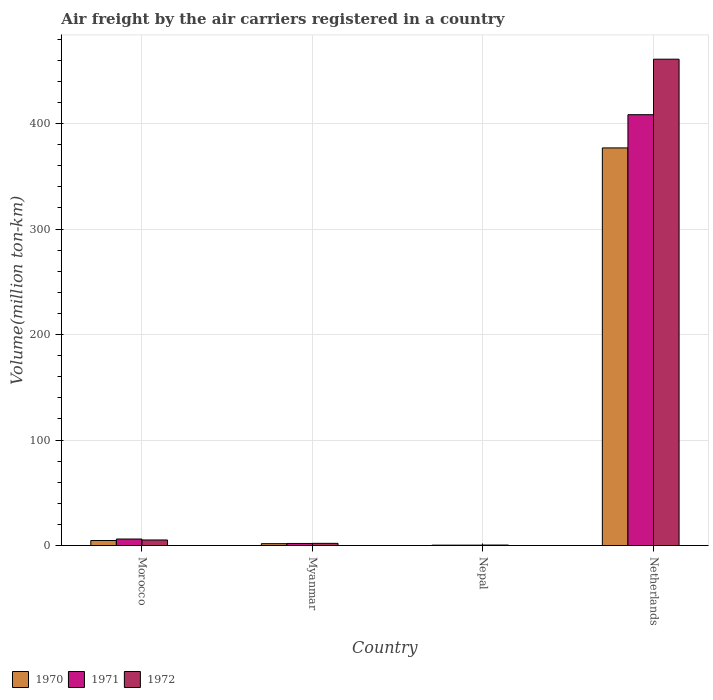How many different coloured bars are there?
Make the answer very short. 3. How many groups of bars are there?
Give a very brief answer. 4. What is the label of the 1st group of bars from the left?
Keep it short and to the point. Morocco. What is the volume of the air carriers in 1971 in Netherlands?
Provide a succinct answer. 408.4. Across all countries, what is the maximum volume of the air carriers in 1970?
Keep it short and to the point. 376.9. Across all countries, what is the minimum volume of the air carriers in 1970?
Offer a very short reply. 0.4. In which country was the volume of the air carriers in 1972 minimum?
Keep it short and to the point. Nepal. What is the total volume of the air carriers in 1970 in the graph?
Provide a succinct answer. 383.9. What is the difference between the volume of the air carriers in 1970 in Morocco and that in Myanmar?
Give a very brief answer. 3. What is the difference between the volume of the air carriers in 1970 in Myanmar and the volume of the air carriers in 1971 in Nepal?
Make the answer very short. 1.4. What is the average volume of the air carriers in 1971 per country?
Your answer should be very brief. 104.25. What is the difference between the volume of the air carriers of/in 1972 and volume of the air carriers of/in 1970 in Netherlands?
Give a very brief answer. 84.1. What is the ratio of the volume of the air carriers in 1972 in Myanmar to that in Nepal?
Keep it short and to the point. 4.2. What is the difference between the highest and the second highest volume of the air carriers in 1971?
Give a very brief answer. 406.4. What is the difference between the highest and the lowest volume of the air carriers in 1971?
Provide a succinct answer. 408. In how many countries, is the volume of the air carriers in 1970 greater than the average volume of the air carriers in 1970 taken over all countries?
Keep it short and to the point. 1. What does the 2nd bar from the left in Nepal represents?
Give a very brief answer. 1971. What does the 1st bar from the right in Morocco represents?
Ensure brevity in your answer.  1972. Is it the case that in every country, the sum of the volume of the air carriers in 1971 and volume of the air carriers in 1972 is greater than the volume of the air carriers in 1970?
Your answer should be very brief. Yes. Are all the bars in the graph horizontal?
Ensure brevity in your answer.  No. What is the difference between two consecutive major ticks on the Y-axis?
Provide a succinct answer. 100. Are the values on the major ticks of Y-axis written in scientific E-notation?
Your answer should be compact. No. How are the legend labels stacked?
Give a very brief answer. Horizontal. What is the title of the graph?
Ensure brevity in your answer.  Air freight by the air carriers registered in a country. Does "1960" appear as one of the legend labels in the graph?
Your answer should be very brief. No. What is the label or title of the X-axis?
Make the answer very short. Country. What is the label or title of the Y-axis?
Provide a succinct answer. Volume(million ton-km). What is the Volume(million ton-km) in 1970 in Morocco?
Your answer should be very brief. 4.8. What is the Volume(million ton-km) of 1971 in Morocco?
Your response must be concise. 6.2. What is the Volume(million ton-km) of 1972 in Morocco?
Give a very brief answer. 5.3. What is the Volume(million ton-km) in 1970 in Myanmar?
Your answer should be compact. 1.8. What is the Volume(million ton-km) of 1972 in Myanmar?
Your answer should be compact. 2.1. What is the Volume(million ton-km) of 1970 in Nepal?
Make the answer very short. 0.4. What is the Volume(million ton-km) in 1971 in Nepal?
Offer a very short reply. 0.4. What is the Volume(million ton-km) in 1970 in Netherlands?
Your answer should be compact. 376.9. What is the Volume(million ton-km) in 1971 in Netherlands?
Offer a very short reply. 408.4. What is the Volume(million ton-km) in 1972 in Netherlands?
Ensure brevity in your answer.  461. Across all countries, what is the maximum Volume(million ton-km) of 1970?
Keep it short and to the point. 376.9. Across all countries, what is the maximum Volume(million ton-km) in 1971?
Make the answer very short. 408.4. Across all countries, what is the maximum Volume(million ton-km) of 1972?
Make the answer very short. 461. Across all countries, what is the minimum Volume(million ton-km) of 1970?
Give a very brief answer. 0.4. Across all countries, what is the minimum Volume(million ton-km) in 1971?
Offer a very short reply. 0.4. What is the total Volume(million ton-km) of 1970 in the graph?
Your response must be concise. 383.9. What is the total Volume(million ton-km) in 1971 in the graph?
Provide a short and direct response. 417. What is the total Volume(million ton-km) of 1972 in the graph?
Ensure brevity in your answer.  468.9. What is the difference between the Volume(million ton-km) of 1970 in Morocco and that in Myanmar?
Make the answer very short. 3. What is the difference between the Volume(million ton-km) in 1970 in Morocco and that in Nepal?
Provide a short and direct response. 4.4. What is the difference between the Volume(million ton-km) in 1971 in Morocco and that in Nepal?
Your answer should be very brief. 5.8. What is the difference between the Volume(million ton-km) of 1970 in Morocco and that in Netherlands?
Give a very brief answer. -372.1. What is the difference between the Volume(million ton-km) in 1971 in Morocco and that in Netherlands?
Your answer should be compact. -402.2. What is the difference between the Volume(million ton-km) of 1972 in Morocco and that in Netherlands?
Your response must be concise. -455.7. What is the difference between the Volume(million ton-km) of 1970 in Myanmar and that in Netherlands?
Provide a succinct answer. -375.1. What is the difference between the Volume(million ton-km) of 1971 in Myanmar and that in Netherlands?
Offer a terse response. -406.4. What is the difference between the Volume(million ton-km) in 1972 in Myanmar and that in Netherlands?
Your response must be concise. -458.9. What is the difference between the Volume(million ton-km) in 1970 in Nepal and that in Netherlands?
Your response must be concise. -376.5. What is the difference between the Volume(million ton-km) of 1971 in Nepal and that in Netherlands?
Provide a succinct answer. -408. What is the difference between the Volume(million ton-km) of 1972 in Nepal and that in Netherlands?
Keep it short and to the point. -460.5. What is the difference between the Volume(million ton-km) of 1970 in Morocco and the Volume(million ton-km) of 1971 in Myanmar?
Ensure brevity in your answer.  2.8. What is the difference between the Volume(million ton-km) in 1970 in Morocco and the Volume(million ton-km) in 1972 in Myanmar?
Provide a short and direct response. 2.7. What is the difference between the Volume(million ton-km) of 1970 in Morocco and the Volume(million ton-km) of 1971 in Netherlands?
Provide a succinct answer. -403.6. What is the difference between the Volume(million ton-km) in 1970 in Morocco and the Volume(million ton-km) in 1972 in Netherlands?
Your answer should be compact. -456.2. What is the difference between the Volume(million ton-km) in 1971 in Morocco and the Volume(million ton-km) in 1972 in Netherlands?
Your answer should be compact. -454.8. What is the difference between the Volume(million ton-km) of 1970 in Myanmar and the Volume(million ton-km) of 1971 in Netherlands?
Your answer should be very brief. -406.6. What is the difference between the Volume(million ton-km) of 1970 in Myanmar and the Volume(million ton-km) of 1972 in Netherlands?
Provide a short and direct response. -459.2. What is the difference between the Volume(million ton-km) of 1971 in Myanmar and the Volume(million ton-km) of 1972 in Netherlands?
Offer a very short reply. -459. What is the difference between the Volume(million ton-km) of 1970 in Nepal and the Volume(million ton-km) of 1971 in Netherlands?
Give a very brief answer. -408. What is the difference between the Volume(million ton-km) in 1970 in Nepal and the Volume(million ton-km) in 1972 in Netherlands?
Make the answer very short. -460.6. What is the difference between the Volume(million ton-km) of 1971 in Nepal and the Volume(million ton-km) of 1972 in Netherlands?
Offer a very short reply. -460.6. What is the average Volume(million ton-km) of 1970 per country?
Your answer should be very brief. 95.97. What is the average Volume(million ton-km) in 1971 per country?
Provide a short and direct response. 104.25. What is the average Volume(million ton-km) in 1972 per country?
Offer a very short reply. 117.22. What is the difference between the Volume(million ton-km) of 1970 and Volume(million ton-km) of 1971 in Morocco?
Your answer should be very brief. -1.4. What is the difference between the Volume(million ton-km) in 1971 and Volume(million ton-km) in 1972 in Morocco?
Offer a very short reply. 0.9. What is the difference between the Volume(million ton-km) of 1970 and Volume(million ton-km) of 1971 in Myanmar?
Provide a short and direct response. -0.2. What is the difference between the Volume(million ton-km) of 1971 and Volume(million ton-km) of 1972 in Myanmar?
Offer a very short reply. -0.1. What is the difference between the Volume(million ton-km) of 1970 and Volume(million ton-km) of 1971 in Nepal?
Keep it short and to the point. 0. What is the difference between the Volume(million ton-km) of 1971 and Volume(million ton-km) of 1972 in Nepal?
Provide a succinct answer. -0.1. What is the difference between the Volume(million ton-km) of 1970 and Volume(million ton-km) of 1971 in Netherlands?
Provide a short and direct response. -31.5. What is the difference between the Volume(million ton-km) in 1970 and Volume(million ton-km) in 1972 in Netherlands?
Offer a very short reply. -84.1. What is the difference between the Volume(million ton-km) of 1971 and Volume(million ton-km) of 1972 in Netherlands?
Provide a succinct answer. -52.6. What is the ratio of the Volume(million ton-km) in 1970 in Morocco to that in Myanmar?
Keep it short and to the point. 2.67. What is the ratio of the Volume(million ton-km) in 1971 in Morocco to that in Myanmar?
Ensure brevity in your answer.  3.1. What is the ratio of the Volume(million ton-km) of 1972 in Morocco to that in Myanmar?
Make the answer very short. 2.52. What is the ratio of the Volume(million ton-km) in 1970 in Morocco to that in Netherlands?
Offer a terse response. 0.01. What is the ratio of the Volume(million ton-km) of 1971 in Morocco to that in Netherlands?
Offer a very short reply. 0.02. What is the ratio of the Volume(million ton-km) of 1972 in Morocco to that in Netherlands?
Offer a terse response. 0.01. What is the ratio of the Volume(million ton-km) in 1970 in Myanmar to that in Nepal?
Your answer should be compact. 4.5. What is the ratio of the Volume(million ton-km) of 1971 in Myanmar to that in Nepal?
Your answer should be very brief. 5. What is the ratio of the Volume(million ton-km) in 1970 in Myanmar to that in Netherlands?
Your answer should be very brief. 0. What is the ratio of the Volume(million ton-km) of 1971 in Myanmar to that in Netherlands?
Your answer should be very brief. 0. What is the ratio of the Volume(million ton-km) of 1972 in Myanmar to that in Netherlands?
Keep it short and to the point. 0. What is the ratio of the Volume(million ton-km) of 1970 in Nepal to that in Netherlands?
Provide a succinct answer. 0. What is the ratio of the Volume(million ton-km) in 1972 in Nepal to that in Netherlands?
Give a very brief answer. 0. What is the difference between the highest and the second highest Volume(million ton-km) of 1970?
Your response must be concise. 372.1. What is the difference between the highest and the second highest Volume(million ton-km) in 1971?
Provide a short and direct response. 402.2. What is the difference between the highest and the second highest Volume(million ton-km) of 1972?
Your answer should be very brief. 455.7. What is the difference between the highest and the lowest Volume(million ton-km) of 1970?
Provide a short and direct response. 376.5. What is the difference between the highest and the lowest Volume(million ton-km) in 1971?
Make the answer very short. 408. What is the difference between the highest and the lowest Volume(million ton-km) of 1972?
Provide a short and direct response. 460.5. 